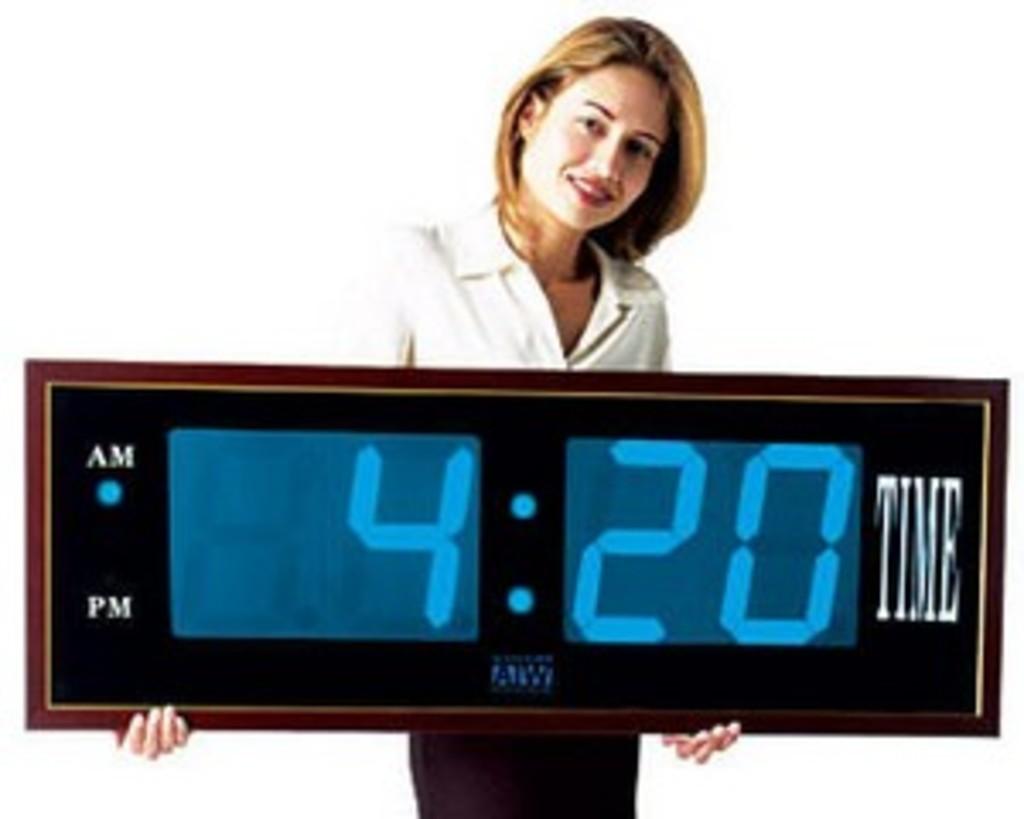What time does the clock say?
Provide a succinct answer. 4:20. 